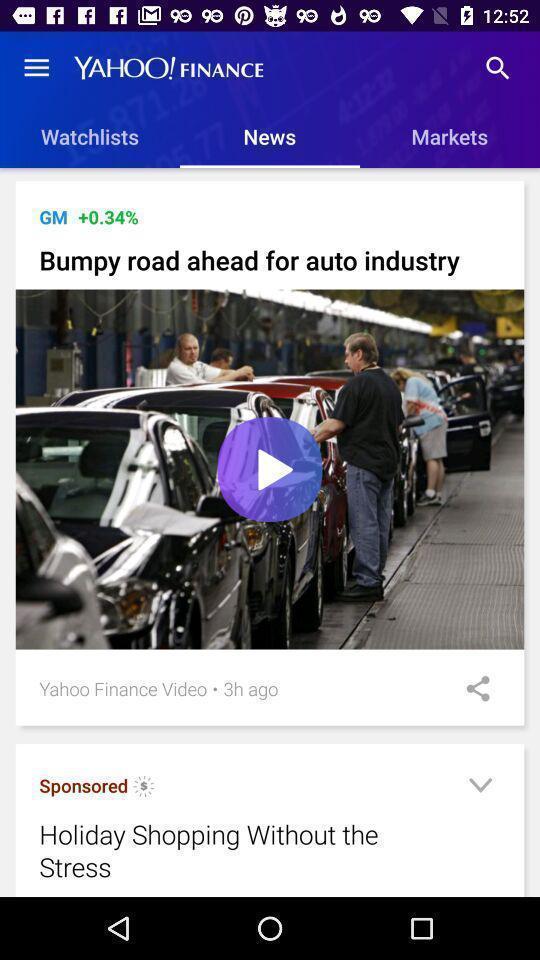Explain what's happening in this screen capture. Screen displaying the new feeds in news tab. 